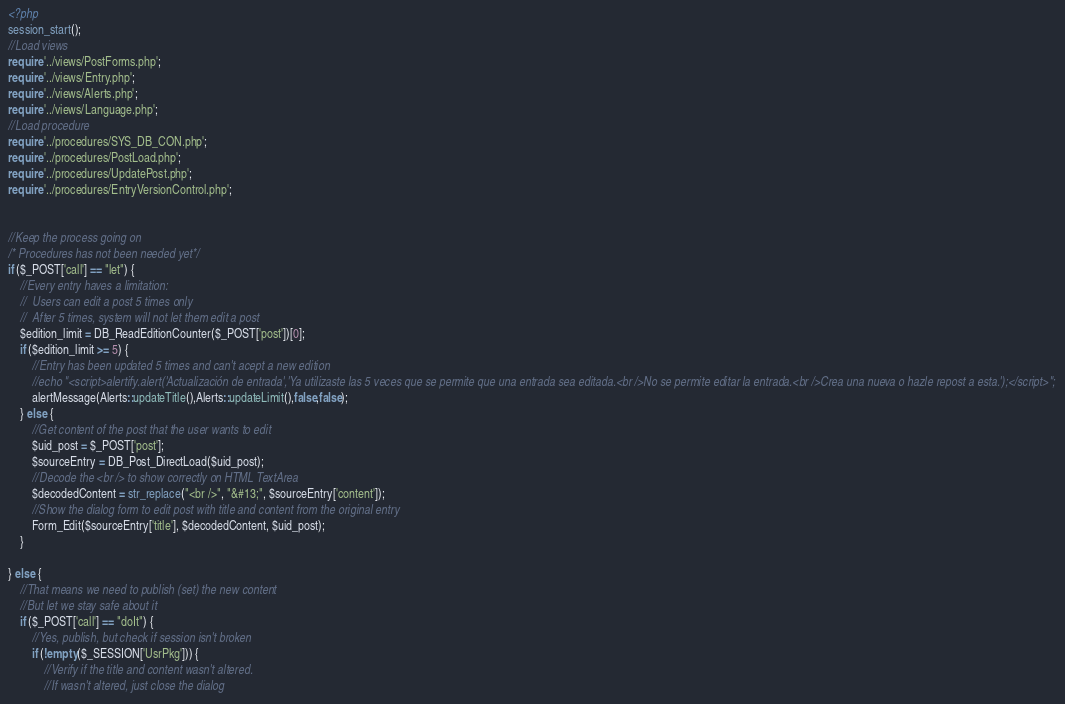Convert code to text. <code><loc_0><loc_0><loc_500><loc_500><_PHP_><?php
session_start();
//Load views
require '../views/PostForms.php';
require '../views/Entry.php';
require '../views/Alerts.php';
require '../views/Language.php';
//Load procedure
require '../procedures/SYS_DB_CON.php';
require '../procedures/PostLoad.php';
require '../procedures/UpdatePost.php';
require '../procedures/EntryVersionControl.php';


//Keep the process going on
/* Procedures has not been needed yet*/
if ($_POST['call'] == "let") {
    //Every entry haves a limitation:
    //  Users can edit a post 5 times only
    //  After 5 times, system will not let them edit a post
    $edition_limit = DB_ReadEditionCounter($_POST['post'])[0];
    if ($edition_limit >= 5) {
        //Entry has been updated 5 times and can't acept a new edition
        //echo "<script>alertify.alert('Actualización de entrada','Ya utilizaste las 5 veces que se permite que una entrada sea editada.<br />No se permite editar la entrada.<br />Crea una nueva o hazle repost a esta.');</script>";
        alertMessage(Alerts::updateTitle(),Alerts::updateLimit(),false,false);
    } else {
        //Get content of the post that the user wants to edit
        $uid_post = $_POST['post'];
        $sourceEntry = DB_Post_DirectLoad($uid_post);
        //Decode the <br /> to show correctly on HTML TextArea
        $decodedContent = str_replace("<br />", "&#13;", $sourceEntry['content']);
        //Show the dialog form to edit post with title and content from the original entry
        Form_Edit($sourceEntry['title'], $decodedContent, $uid_post);
    }
    
} else {
    //That means we need to publish (set) the new content
    //But let we stay safe about it
    if ($_POST['call'] == "doIt") {
        //Yes, publish, but check if session isn't broken
        if (!empty($_SESSION['UsrPkg'])) {
            //Verify if the title and content wasn't altered. 
            //If wasn't altered, just close the dialog</code> 